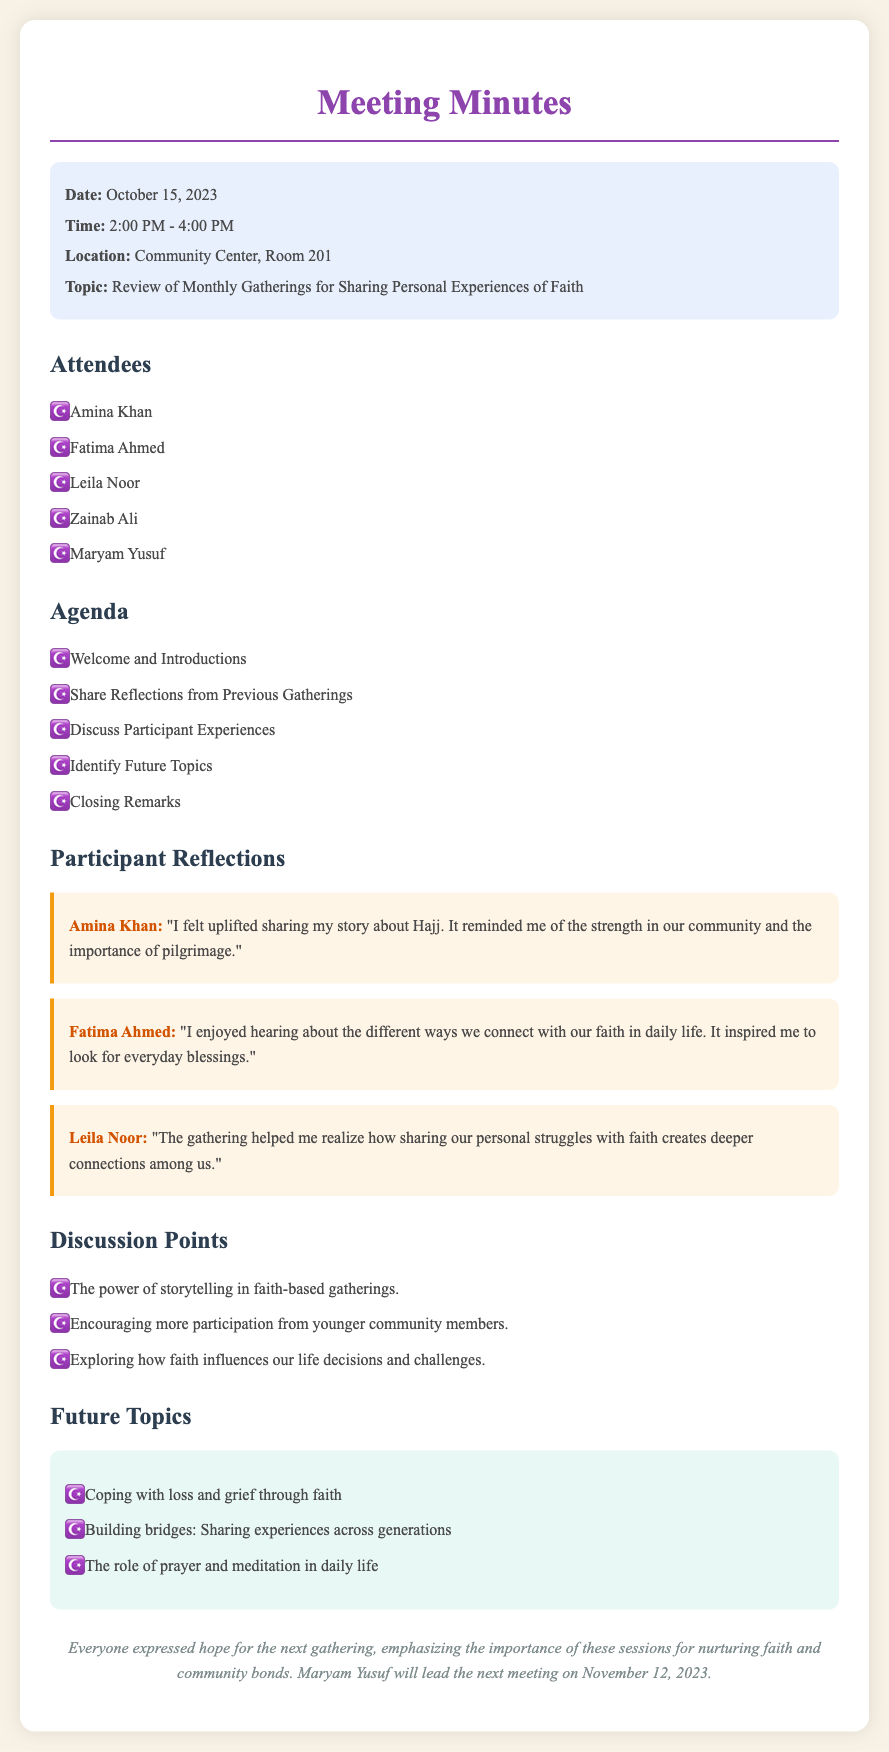What is the date of the meeting? The date of the meeting is mentioned in the document, which is October 15, 2023.
Answer: October 15, 2023 What time did the meeting start? The meeting start time is provided as part of the meeting information.
Answer: 2:00 PM Who will lead the next meeting? The document explicitly states that Maryam Yusuf will lead the next meeting.
Answer: Maryam Yusuf What reflection did Amina Khan share? Amina Khan's reflection about her story on Hajj is provided in the document.
Answer: "I felt uplifted sharing my story about Hajj." What future topic discusses grief? The document mentions a specific future topic related to coping with loss.
Answer: Coping with loss and grief through faith What is one of the discussion points? One of the discussion points revolves around storytelling in faith-based gatherings.
Answer: The power of storytelling in faith-based gatherings How many attendees were present? The list of attendees provides the count of attendees present at the meeting.
Answer: Five What is the location of the meeting? The location is specified in the document under meeting information.
Answer: Community Center, Room 201 